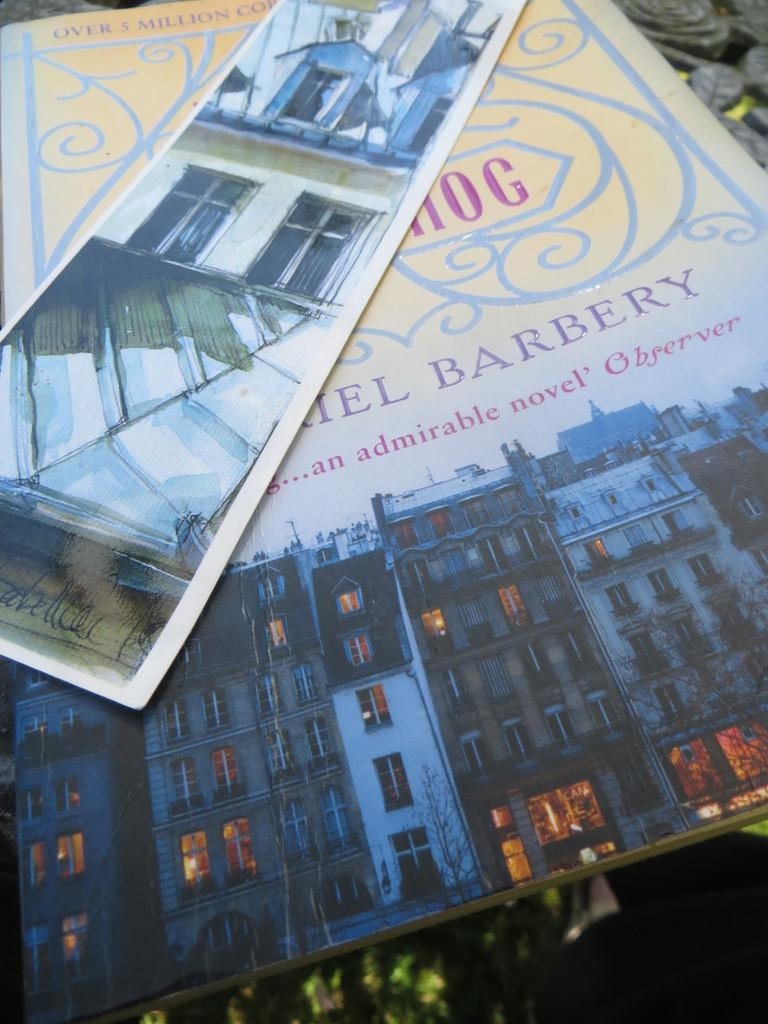What object can be seen in the picture? There is a book in the picture. What is depicted on the book? The book has a drawing of a building on it. Can you see a boat in the picture? No, there is no boat present in the image. What things are depicted in the drawing on the book? The drawing on the book depicts a building, and there are no other things mentioned in the provided facts. 